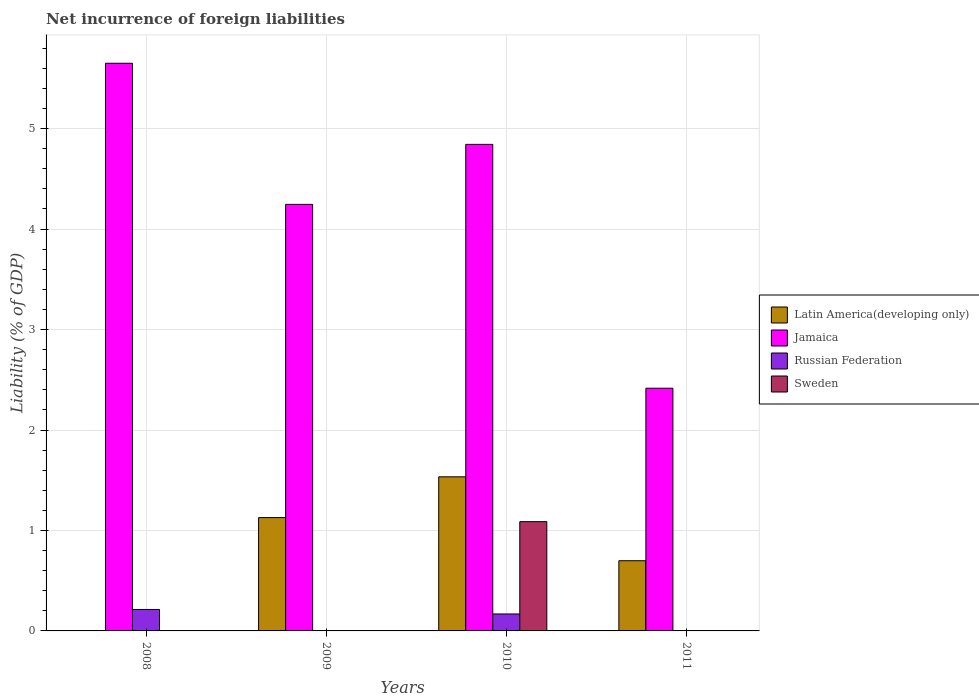Are the number of bars on each tick of the X-axis equal?
Keep it short and to the point. No. What is the label of the 2nd group of bars from the left?
Make the answer very short. 2009. What is the net incurrence of foreign liabilities in Sweden in 2008?
Provide a succinct answer. 0. Across all years, what is the maximum net incurrence of foreign liabilities in Jamaica?
Provide a succinct answer. 5.65. Across all years, what is the minimum net incurrence of foreign liabilities in Jamaica?
Provide a short and direct response. 2.42. What is the total net incurrence of foreign liabilities in Sweden in the graph?
Your answer should be compact. 1.09. What is the difference between the net incurrence of foreign liabilities in Russian Federation in 2008 and that in 2010?
Your response must be concise. 0.04. What is the difference between the net incurrence of foreign liabilities in Jamaica in 2011 and the net incurrence of foreign liabilities in Latin America(developing only) in 2009?
Your answer should be compact. 1.29. What is the average net incurrence of foreign liabilities in Sweden per year?
Keep it short and to the point. 0.27. In the year 2010, what is the difference between the net incurrence of foreign liabilities in Russian Federation and net incurrence of foreign liabilities in Latin America(developing only)?
Your answer should be very brief. -1.37. In how many years, is the net incurrence of foreign liabilities in Jamaica greater than 2.8 %?
Give a very brief answer. 3. What is the ratio of the net incurrence of foreign liabilities in Latin America(developing only) in 2010 to that in 2011?
Ensure brevity in your answer.  2.2. Is the net incurrence of foreign liabilities in Russian Federation in 2008 less than that in 2010?
Ensure brevity in your answer.  No. What is the difference between the highest and the second highest net incurrence of foreign liabilities in Latin America(developing only)?
Make the answer very short. 0.41. What is the difference between the highest and the lowest net incurrence of foreign liabilities in Latin America(developing only)?
Give a very brief answer. 1.53. In how many years, is the net incurrence of foreign liabilities in Russian Federation greater than the average net incurrence of foreign liabilities in Russian Federation taken over all years?
Your answer should be very brief. 2. Is it the case that in every year, the sum of the net incurrence of foreign liabilities in Jamaica and net incurrence of foreign liabilities in Russian Federation is greater than the net incurrence of foreign liabilities in Latin America(developing only)?
Offer a terse response. Yes. Are all the bars in the graph horizontal?
Provide a short and direct response. No. Does the graph contain any zero values?
Your answer should be compact. Yes. Does the graph contain grids?
Your response must be concise. Yes. How many legend labels are there?
Offer a very short reply. 4. How are the legend labels stacked?
Keep it short and to the point. Vertical. What is the title of the graph?
Your response must be concise. Net incurrence of foreign liabilities. Does "Philippines" appear as one of the legend labels in the graph?
Ensure brevity in your answer.  No. What is the label or title of the X-axis?
Your response must be concise. Years. What is the label or title of the Y-axis?
Provide a succinct answer. Liability (% of GDP). What is the Liability (% of GDP) of Latin America(developing only) in 2008?
Make the answer very short. 0. What is the Liability (% of GDP) of Jamaica in 2008?
Keep it short and to the point. 5.65. What is the Liability (% of GDP) of Russian Federation in 2008?
Your answer should be very brief. 0.21. What is the Liability (% of GDP) in Sweden in 2008?
Your answer should be compact. 0. What is the Liability (% of GDP) of Latin America(developing only) in 2009?
Make the answer very short. 1.13. What is the Liability (% of GDP) in Jamaica in 2009?
Ensure brevity in your answer.  4.25. What is the Liability (% of GDP) of Latin America(developing only) in 2010?
Ensure brevity in your answer.  1.53. What is the Liability (% of GDP) in Jamaica in 2010?
Provide a short and direct response. 4.84. What is the Liability (% of GDP) in Russian Federation in 2010?
Your answer should be very brief. 0.17. What is the Liability (% of GDP) of Sweden in 2010?
Your response must be concise. 1.09. What is the Liability (% of GDP) of Latin America(developing only) in 2011?
Your answer should be compact. 0.7. What is the Liability (% of GDP) in Jamaica in 2011?
Your answer should be compact. 2.42. Across all years, what is the maximum Liability (% of GDP) in Latin America(developing only)?
Your answer should be compact. 1.53. Across all years, what is the maximum Liability (% of GDP) in Jamaica?
Your answer should be very brief. 5.65. Across all years, what is the maximum Liability (% of GDP) in Russian Federation?
Offer a very short reply. 0.21. Across all years, what is the maximum Liability (% of GDP) in Sweden?
Offer a terse response. 1.09. Across all years, what is the minimum Liability (% of GDP) in Jamaica?
Offer a terse response. 2.42. What is the total Liability (% of GDP) of Latin America(developing only) in the graph?
Ensure brevity in your answer.  3.36. What is the total Liability (% of GDP) of Jamaica in the graph?
Keep it short and to the point. 17.16. What is the total Liability (% of GDP) of Russian Federation in the graph?
Give a very brief answer. 0.38. What is the total Liability (% of GDP) of Sweden in the graph?
Your response must be concise. 1.09. What is the difference between the Liability (% of GDP) of Jamaica in 2008 and that in 2009?
Your response must be concise. 1.4. What is the difference between the Liability (% of GDP) in Jamaica in 2008 and that in 2010?
Keep it short and to the point. 0.81. What is the difference between the Liability (% of GDP) of Russian Federation in 2008 and that in 2010?
Offer a terse response. 0.04. What is the difference between the Liability (% of GDP) of Jamaica in 2008 and that in 2011?
Provide a short and direct response. 3.23. What is the difference between the Liability (% of GDP) of Latin America(developing only) in 2009 and that in 2010?
Your answer should be very brief. -0.41. What is the difference between the Liability (% of GDP) in Jamaica in 2009 and that in 2010?
Offer a terse response. -0.6. What is the difference between the Liability (% of GDP) in Latin America(developing only) in 2009 and that in 2011?
Your answer should be compact. 0.43. What is the difference between the Liability (% of GDP) of Jamaica in 2009 and that in 2011?
Offer a terse response. 1.83. What is the difference between the Liability (% of GDP) in Latin America(developing only) in 2010 and that in 2011?
Provide a succinct answer. 0.84. What is the difference between the Liability (% of GDP) in Jamaica in 2010 and that in 2011?
Ensure brevity in your answer.  2.43. What is the difference between the Liability (% of GDP) in Jamaica in 2008 and the Liability (% of GDP) in Russian Federation in 2010?
Offer a terse response. 5.48. What is the difference between the Liability (% of GDP) of Jamaica in 2008 and the Liability (% of GDP) of Sweden in 2010?
Offer a very short reply. 4.56. What is the difference between the Liability (% of GDP) in Russian Federation in 2008 and the Liability (% of GDP) in Sweden in 2010?
Make the answer very short. -0.87. What is the difference between the Liability (% of GDP) in Latin America(developing only) in 2009 and the Liability (% of GDP) in Jamaica in 2010?
Provide a succinct answer. -3.72. What is the difference between the Liability (% of GDP) of Latin America(developing only) in 2009 and the Liability (% of GDP) of Russian Federation in 2010?
Your answer should be very brief. 0.96. What is the difference between the Liability (% of GDP) of Latin America(developing only) in 2009 and the Liability (% of GDP) of Sweden in 2010?
Your answer should be compact. 0.04. What is the difference between the Liability (% of GDP) of Jamaica in 2009 and the Liability (% of GDP) of Russian Federation in 2010?
Ensure brevity in your answer.  4.08. What is the difference between the Liability (% of GDP) of Jamaica in 2009 and the Liability (% of GDP) of Sweden in 2010?
Your response must be concise. 3.16. What is the difference between the Liability (% of GDP) of Latin America(developing only) in 2009 and the Liability (% of GDP) of Jamaica in 2011?
Your answer should be very brief. -1.29. What is the difference between the Liability (% of GDP) of Latin America(developing only) in 2010 and the Liability (% of GDP) of Jamaica in 2011?
Provide a short and direct response. -0.88. What is the average Liability (% of GDP) of Latin America(developing only) per year?
Offer a terse response. 0.84. What is the average Liability (% of GDP) of Jamaica per year?
Provide a succinct answer. 4.29. What is the average Liability (% of GDP) in Russian Federation per year?
Give a very brief answer. 0.1. What is the average Liability (% of GDP) of Sweden per year?
Ensure brevity in your answer.  0.27. In the year 2008, what is the difference between the Liability (% of GDP) in Jamaica and Liability (% of GDP) in Russian Federation?
Your answer should be compact. 5.44. In the year 2009, what is the difference between the Liability (% of GDP) of Latin America(developing only) and Liability (% of GDP) of Jamaica?
Provide a succinct answer. -3.12. In the year 2010, what is the difference between the Liability (% of GDP) in Latin America(developing only) and Liability (% of GDP) in Jamaica?
Your response must be concise. -3.31. In the year 2010, what is the difference between the Liability (% of GDP) of Latin America(developing only) and Liability (% of GDP) of Russian Federation?
Keep it short and to the point. 1.37. In the year 2010, what is the difference between the Liability (% of GDP) in Latin America(developing only) and Liability (% of GDP) in Sweden?
Your answer should be very brief. 0.45. In the year 2010, what is the difference between the Liability (% of GDP) in Jamaica and Liability (% of GDP) in Russian Federation?
Keep it short and to the point. 4.67. In the year 2010, what is the difference between the Liability (% of GDP) of Jamaica and Liability (% of GDP) of Sweden?
Offer a very short reply. 3.76. In the year 2010, what is the difference between the Liability (% of GDP) in Russian Federation and Liability (% of GDP) in Sweden?
Provide a succinct answer. -0.92. In the year 2011, what is the difference between the Liability (% of GDP) of Latin America(developing only) and Liability (% of GDP) of Jamaica?
Keep it short and to the point. -1.72. What is the ratio of the Liability (% of GDP) in Jamaica in 2008 to that in 2009?
Your answer should be very brief. 1.33. What is the ratio of the Liability (% of GDP) of Russian Federation in 2008 to that in 2010?
Provide a short and direct response. 1.27. What is the ratio of the Liability (% of GDP) in Jamaica in 2008 to that in 2011?
Offer a very short reply. 2.34. What is the ratio of the Liability (% of GDP) in Latin America(developing only) in 2009 to that in 2010?
Make the answer very short. 0.74. What is the ratio of the Liability (% of GDP) in Jamaica in 2009 to that in 2010?
Make the answer very short. 0.88. What is the ratio of the Liability (% of GDP) in Latin America(developing only) in 2009 to that in 2011?
Provide a succinct answer. 1.61. What is the ratio of the Liability (% of GDP) in Jamaica in 2009 to that in 2011?
Make the answer very short. 1.76. What is the ratio of the Liability (% of GDP) of Latin America(developing only) in 2010 to that in 2011?
Give a very brief answer. 2.2. What is the ratio of the Liability (% of GDP) of Jamaica in 2010 to that in 2011?
Ensure brevity in your answer.  2. What is the difference between the highest and the second highest Liability (% of GDP) of Latin America(developing only)?
Offer a terse response. 0.41. What is the difference between the highest and the second highest Liability (% of GDP) in Jamaica?
Offer a terse response. 0.81. What is the difference between the highest and the lowest Liability (% of GDP) in Latin America(developing only)?
Offer a terse response. 1.53. What is the difference between the highest and the lowest Liability (% of GDP) of Jamaica?
Make the answer very short. 3.23. What is the difference between the highest and the lowest Liability (% of GDP) in Russian Federation?
Keep it short and to the point. 0.21. What is the difference between the highest and the lowest Liability (% of GDP) of Sweden?
Give a very brief answer. 1.09. 